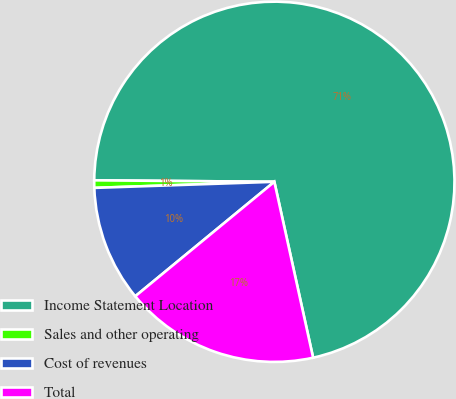<chart> <loc_0><loc_0><loc_500><loc_500><pie_chart><fcel>Income Statement Location<fcel>Sales and other operating<fcel>Cost of revenues<fcel>Total<nl><fcel>71.41%<fcel>0.67%<fcel>10.42%<fcel>17.49%<nl></chart> 